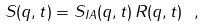<formula> <loc_0><loc_0><loc_500><loc_500>S ( q , t ) = S _ { I A } ( q , t ) \, R ( q , t ) \ ,</formula> 